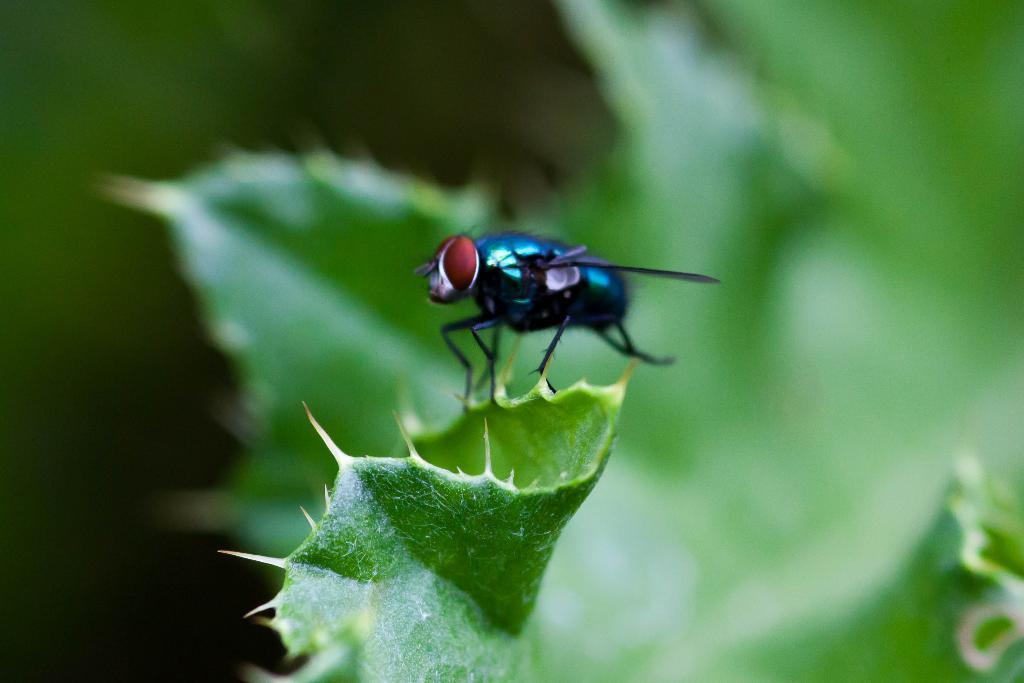What is the main subject of the image? The main subject of the image is a house fly. Where is the house fly located in the image? The house fly is on a leaf. Can you describe the background of the image? The background of the image is blurred. What type of wire is the dog using for learning in the image? There is no wire or dog present in the image; it features a house fly on a leaf. 